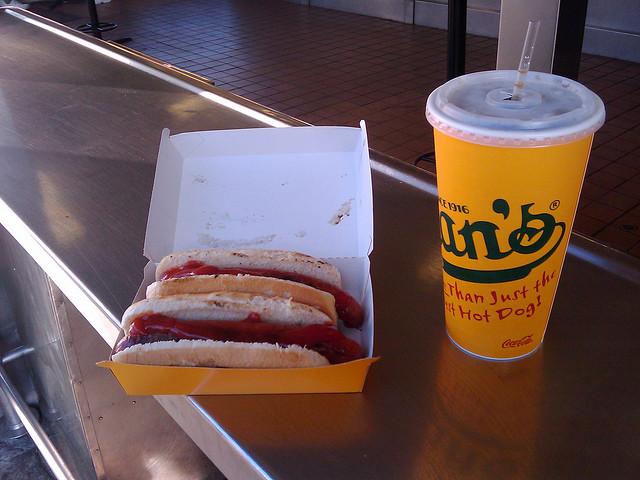What does the text at the very bottom of the cup say?
Short answer required. Coca cola. What kind of store is shown here?
Write a very short answer. Nathan's. What condiment is on the hot dogs?
Short answer required. Ketchup. What company is on the cup?
Short answer required. Nathan's. 